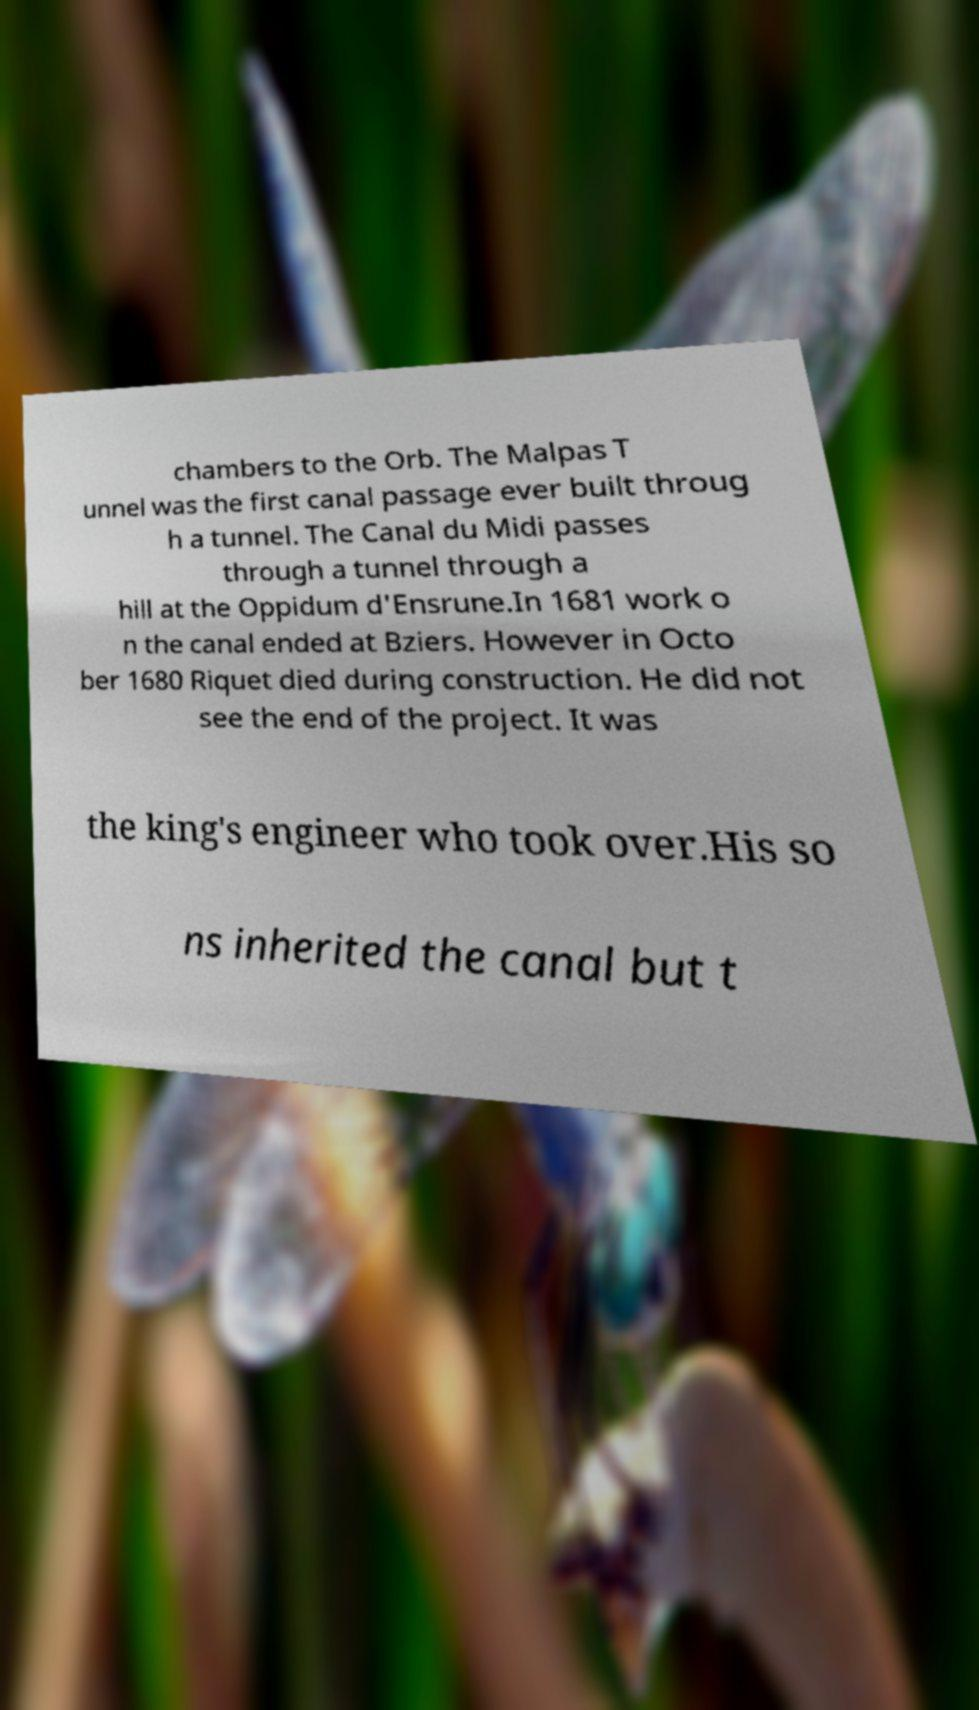Can you accurately transcribe the text from the provided image for me? chambers to the Orb. The Malpas T unnel was the first canal passage ever built throug h a tunnel. The Canal du Midi passes through a tunnel through a hill at the Oppidum d'Ensrune.In 1681 work o n the canal ended at Bziers. However in Octo ber 1680 Riquet died during construction. He did not see the end of the project. It was the king's engineer who took over.His so ns inherited the canal but t 